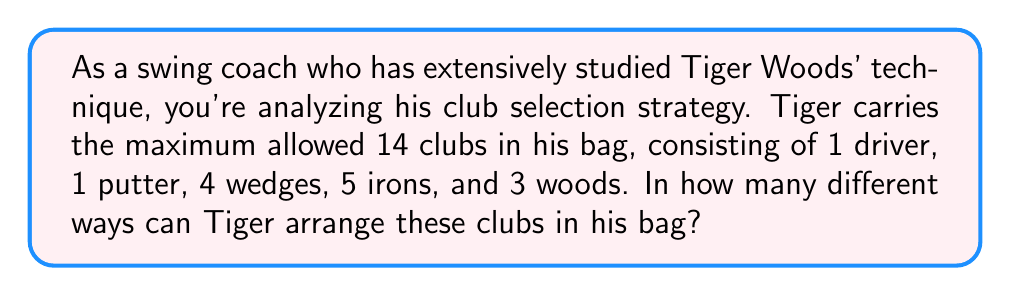Solve this math problem. Let's approach this step-by-step:

1) First, we need to recognize that this is a permutation problem. We're arranging 14 distinct items (clubs) in a specific order.

2) The formula for permutations of n distinct objects is:

   $$P(n) = n!$$

3) In this case, n = 14 (total number of clubs).

4) Therefore, the number of ways to arrange the clubs is:

   $$14! = 14 \times 13 \times 12 \times 11 \times ... \times 2 \times 1$$

5) Let's calculate this:
   
   $$14! = 87,178,291,200$$

6) It's worth noting that while we specified the types of clubs (1 driver, 1 putter, 4 wedges, 5 irons, and 3 woods), each club is considered distinct. For example, each of the 5 irons could be a different number (2-iron, 3-iron, etc.), making them all unique.

7) If we were considering the clubs as indistinguishable within their types, we would need to use a different formula (multinomial coefficient), but that's not the case in this problem.
Answer: $87,178,291,200$ 